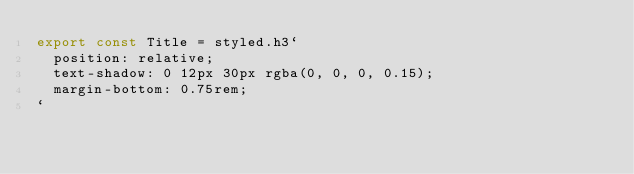<code> <loc_0><loc_0><loc_500><loc_500><_TypeScript_>export const Title = styled.h3`
  position: relative;
  text-shadow: 0 12px 30px rgba(0, 0, 0, 0.15);
  margin-bottom: 0.75rem;
`
</code> 